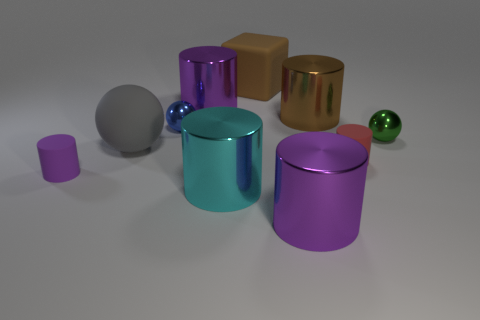There is a big metallic thing that is the same color as the large matte block; what is its shape?
Your answer should be compact. Cylinder. What is the size of the gray thing that is the same material as the brown cube?
Your answer should be compact. Large. Are there any other things that are the same color as the big ball?
Provide a short and direct response. No. There is a tiny object that is to the left of the big ball; what color is it?
Ensure brevity in your answer.  Purple. There is a purple metallic cylinder in front of the purple rubber thing to the left of the red matte cylinder; are there any purple things that are in front of it?
Provide a succinct answer. No. Is the number of purple metal cylinders that are in front of the gray matte ball greater than the number of large red shiny objects?
Offer a very short reply. Yes. Do the large matte object that is in front of the large matte cube and the blue shiny thing have the same shape?
Provide a short and direct response. Yes. How many things are either red shiny cylinders or large cylinders in front of the gray sphere?
Ensure brevity in your answer.  2. How big is the sphere that is left of the red matte cylinder and behind the large gray matte ball?
Keep it short and to the point. Small. Is the number of objects to the right of the blue metallic sphere greater than the number of tiny red objects that are on the right side of the big brown matte block?
Provide a short and direct response. Yes. 